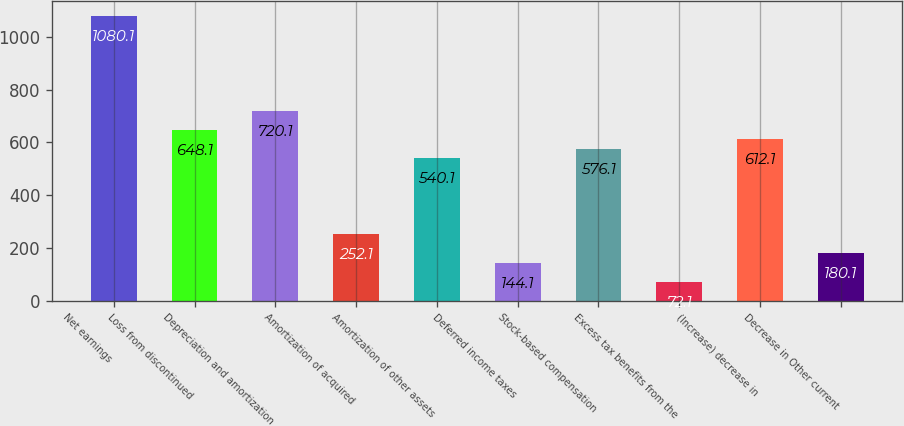<chart> <loc_0><loc_0><loc_500><loc_500><bar_chart><fcel>Net earnings<fcel>Loss from discontinued<fcel>Depreciation and amortization<fcel>Amortization of acquired<fcel>Amortization of other assets<fcel>Deferred income taxes<fcel>Stock-based compensation<fcel>Excess tax benefits from the<fcel>(Increase) decrease in<fcel>Decrease in Other current<nl><fcel>1080.1<fcel>648.1<fcel>720.1<fcel>252.1<fcel>540.1<fcel>144.1<fcel>576.1<fcel>72.1<fcel>612.1<fcel>180.1<nl></chart> 